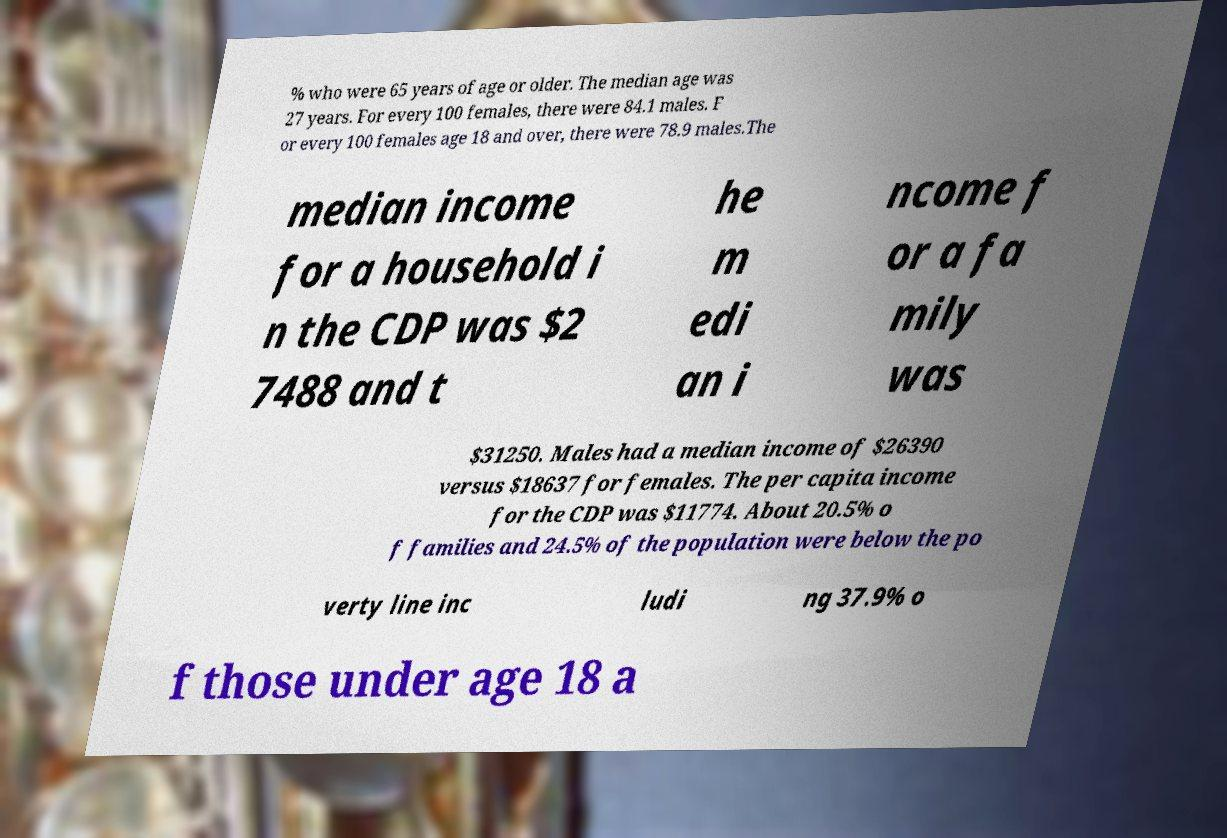Please read and relay the text visible in this image. What does it say? % who were 65 years of age or older. The median age was 27 years. For every 100 females, there were 84.1 males. F or every 100 females age 18 and over, there were 78.9 males.The median income for a household i n the CDP was $2 7488 and t he m edi an i ncome f or a fa mily was $31250. Males had a median income of $26390 versus $18637 for females. The per capita income for the CDP was $11774. About 20.5% o f families and 24.5% of the population were below the po verty line inc ludi ng 37.9% o f those under age 18 a 